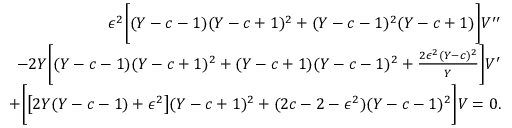Convert formula to latex. <formula><loc_0><loc_0><loc_500><loc_500>\begin{array} { r } { \epsilon ^ { 2 } \left [ ( Y - c - 1 ) ( Y - c + 1 ) ^ { 2 } + ( Y - c - 1 ) ^ { 2 } ( Y - c + 1 ) \right ] V ^ { \prime \prime } } \\ { - 2 Y \left [ ( Y - c - 1 ) ( Y - c + 1 ) ^ { 2 } + ( Y - c + 1 ) ( Y - c - 1 ) ^ { 2 } + \frac { 2 \epsilon ^ { 2 } ( Y - c ) ^ { 2 } } { Y } \right ] V ^ { \prime } } \\ { + \left [ \left [ 2 Y ( Y - c - 1 ) + \epsilon ^ { 2 } \right ] ( Y - c + 1 ) ^ { 2 } + ( 2 c - 2 - \epsilon ^ { 2 } ) ( Y - c - 1 ) ^ { 2 } \right ] V = 0 . } \end{array}</formula> 